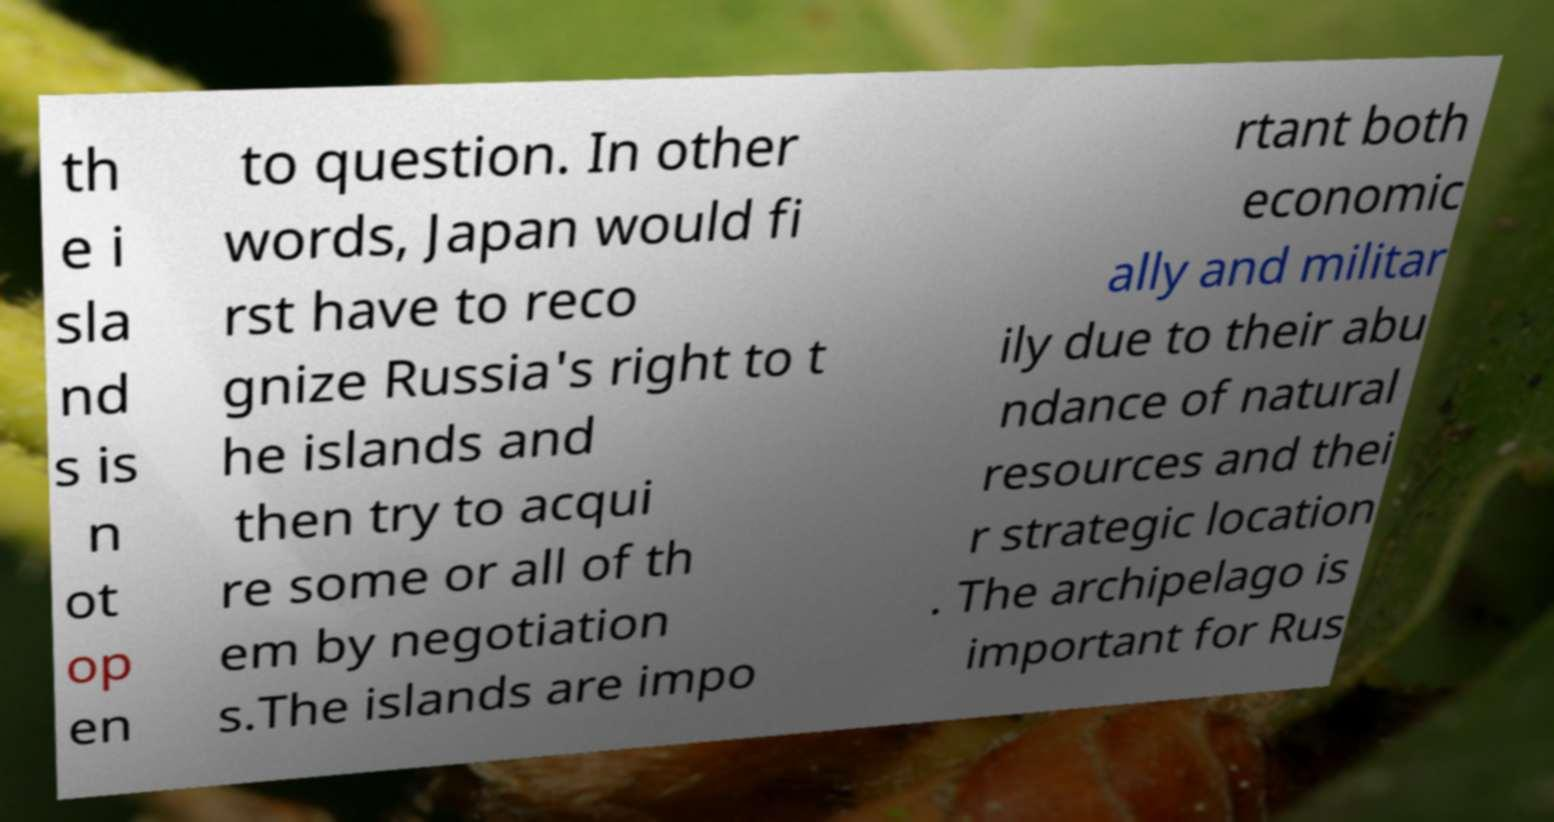Could you assist in decoding the text presented in this image and type it out clearly? th e i sla nd s is n ot op en to question. In other words, Japan would fi rst have to reco gnize Russia's right to t he islands and then try to acqui re some or all of th em by negotiation s.The islands are impo rtant both economic ally and militar ily due to their abu ndance of natural resources and thei r strategic location . The archipelago is important for Rus 